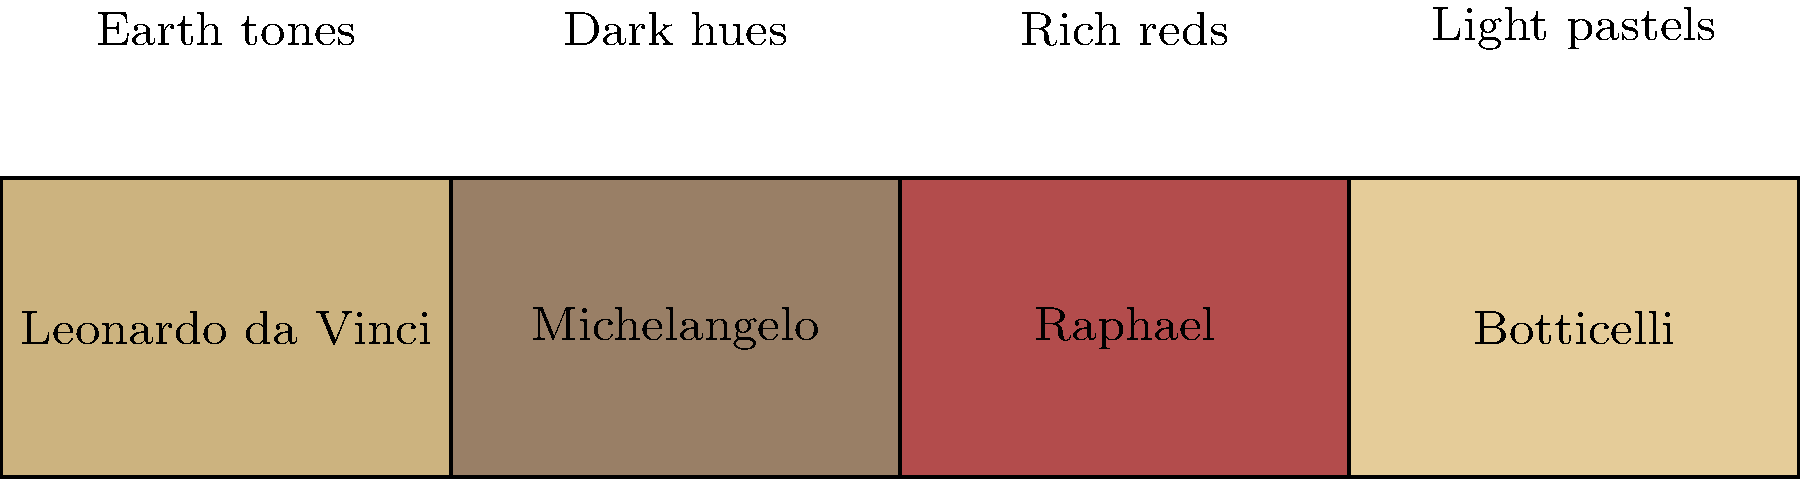Match the Renaissance artists to their signature color palettes based on their most famous works. Which artist is known for using rich reds in their paintings? To answer this question, we need to analyze the color palettes associated with each Renaissance artist:

1. Leonardo da Vinci: Known for his sfumato technique, he often used earth tones and subtle shading. His palette is represented by muted browns and golds.

2. Michelangelo: Famous for his frescoes and sculptures, he used darker hues and strong contrasts. His palette is shown as deep, somber colors.

3. Raphael: Renowned for his use of vibrant colors, particularly rich reds. His palette is depicted with warm, intense red tones.

4. Botticelli: Characterized by his use of light, delicate colors. His palette is represented by soft, pastel hues.

By examining the color palettes provided in the image and matching them to the descriptions of each artist's typical color usage, we can determine that Raphael is associated with the rich red palette.
Answer: Raphael 